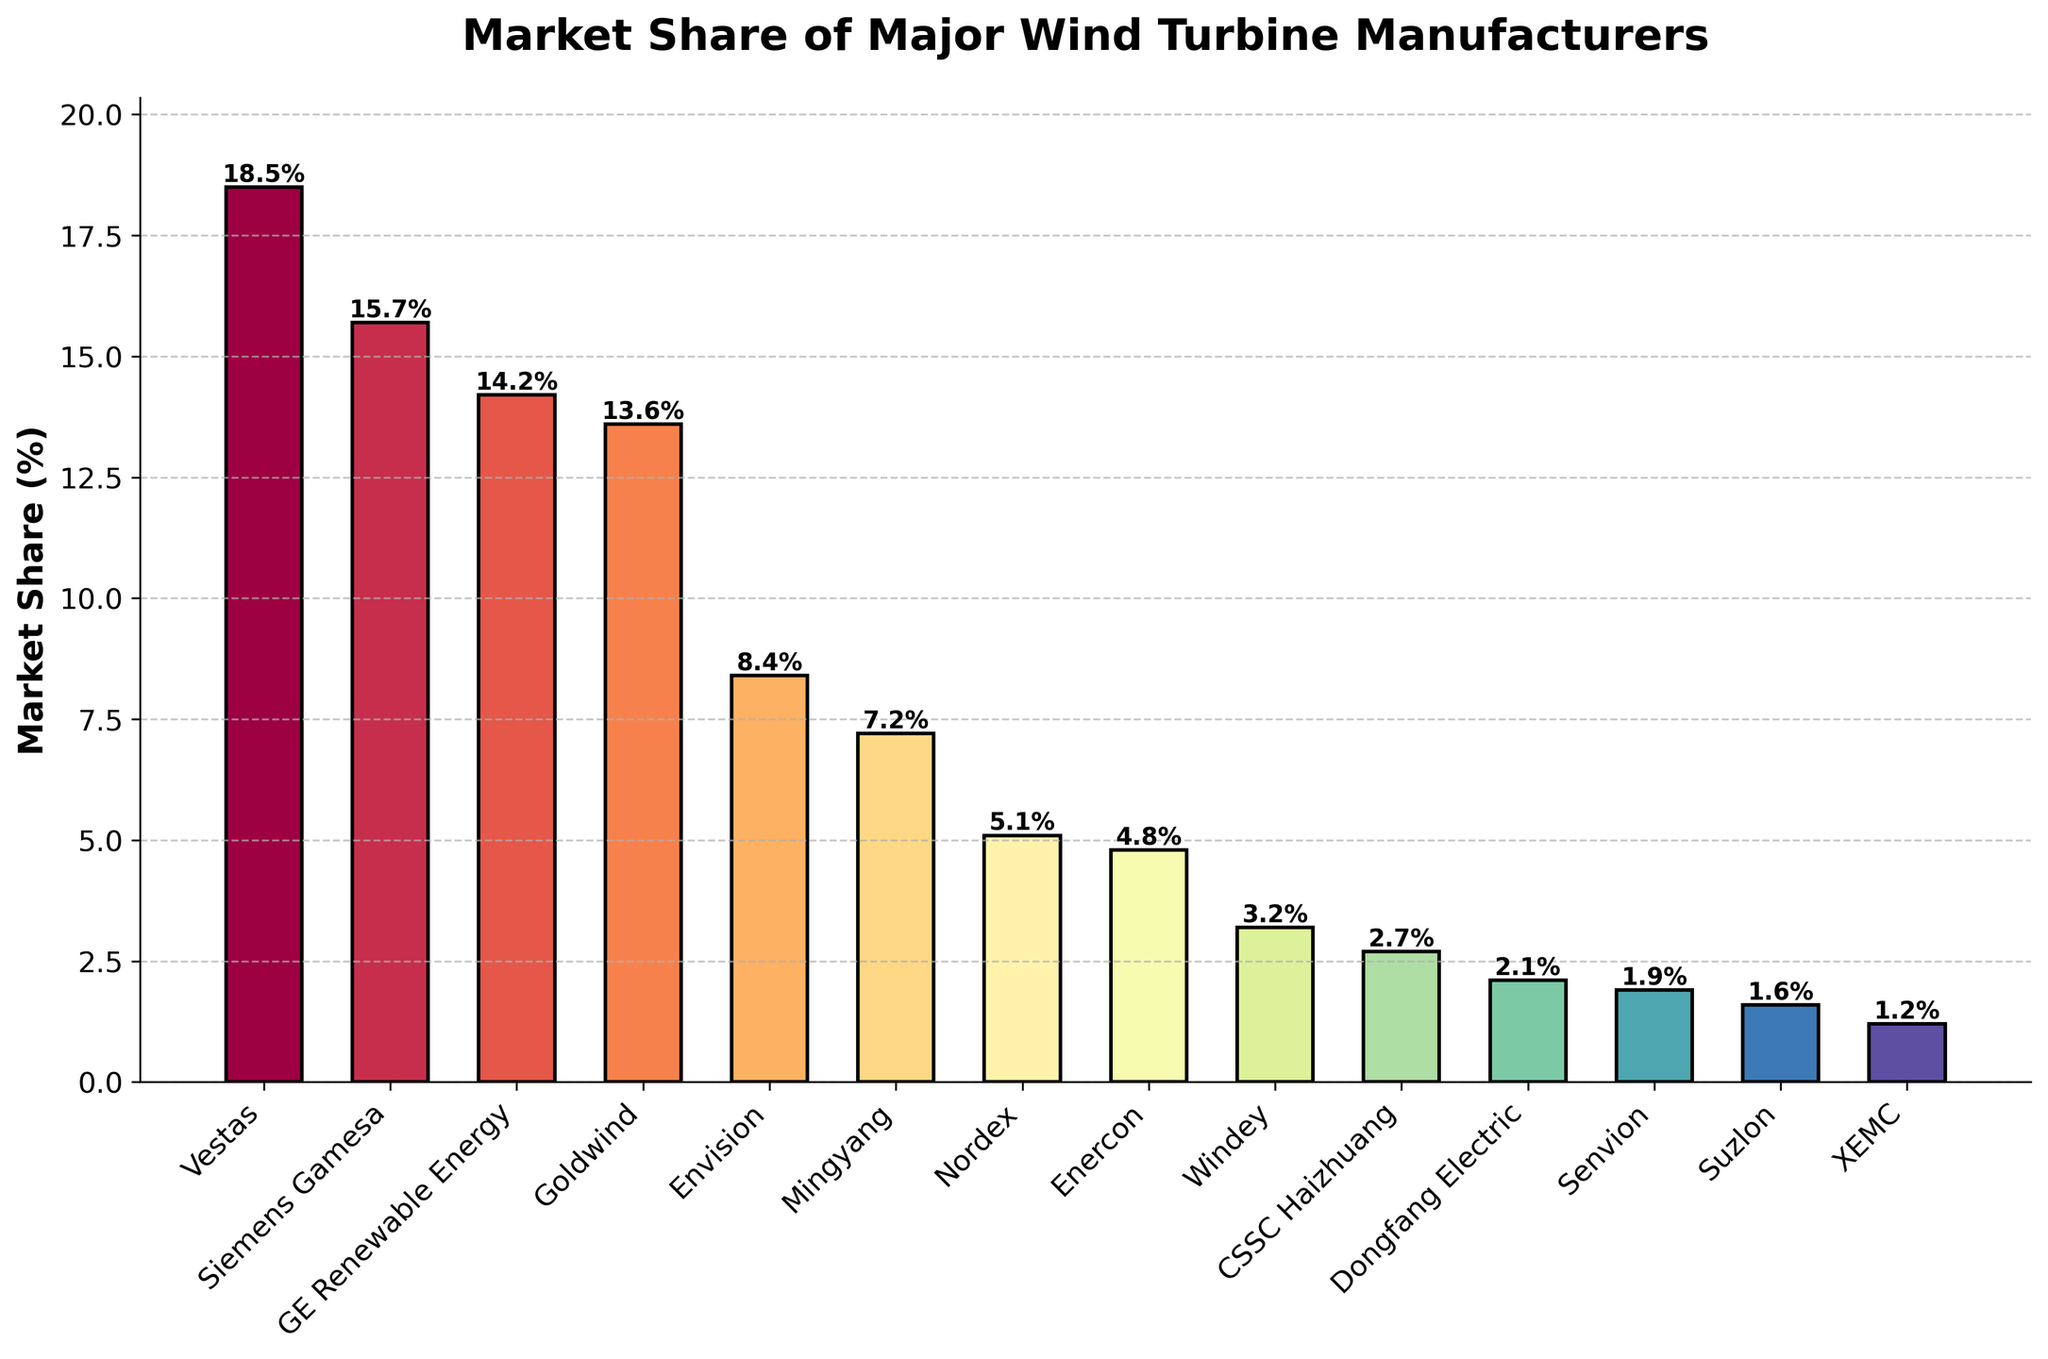Which manufacturer has the highest market share? Vestas has the highest market share because its bar is the tallest among all manufacturers.
Answer: Vestas How much higher is Vestas' market share compared to Goldwind's? Vestas has a market share of 18.5%, and Goldwind has 13.6%. The difference is 18.5% - 13.6% = 4.9%.
Answer: 4.9% What's the combined market share of the top three manufacturers? The market shares of Vestas, Siemens Gamesa, and GE Renewable Energy are 18.5%, 15.7%, and 14.2% respectively. The sum is 18.5% + 15.7% + 14.2% = 48.4%.
Answer: 48.4% Which manufacturers have a market share less than 3%? The manufacturers with market shares less than 3% are CSSC Haizhuang, Dongfang Electric, Senvion, Suzlon, and XEMC.
Answer: CSSC Haizhuang, Dongfang Electric, Senvion, Suzlon, XEMC What's the difference in market share between Envision and Mingyang? Envision has a market share of 8.4%, and Mingyang has 7.2%. The difference is 8.4% - 7.2% = 1.2%.
Answer: 1.2% What is the average market share of the top five manufacturers? The market shares of the top five manufacturers (Vestas, Siemens Gamesa, GE Renewable Energy, Goldwind, Envision) are 18.5%, 15.7%, 14.2%, 13.6%, and 8.4%. The sum is 18.5% + 15.7% + 14.2% + 13.6% + 8.4% = 70.4%, and the average is 70.4% / 5 = 14.08%.
Answer: 14.08% Which manufacturer has the market share closest to 5%? Nordex has a market share of 5.1%, which is the closest to 5%.
Answer: Nordex Which manufacturers' bars are colored differently compared to the others? All bars are colored differently due to the use of a color map, so each manufacturer's bar has a unique shade.
Answer: All manufacturers How does the market share of Enercon compare to that of Windey? Enercon has a market share of 4.8%, and Windey has 3.2%. Enercon's market share is higher.
Answer: Enercon What's the sum of the market shares for manufacturers whose market share is below 5%? The manufacturers are Windey, CSSC Haizhuang, Dongfang Electric, Senvion, Suzlon, and XEMC with market shares of 3.2%, 2.7%, 2.1%, 1.9%, 1.6%, and 1.2%. The sum is 3.2% + 2.7% + 2.1% + 1.9% + 1.6% + 1.2% = 12.7%.
Answer: 12.7% 